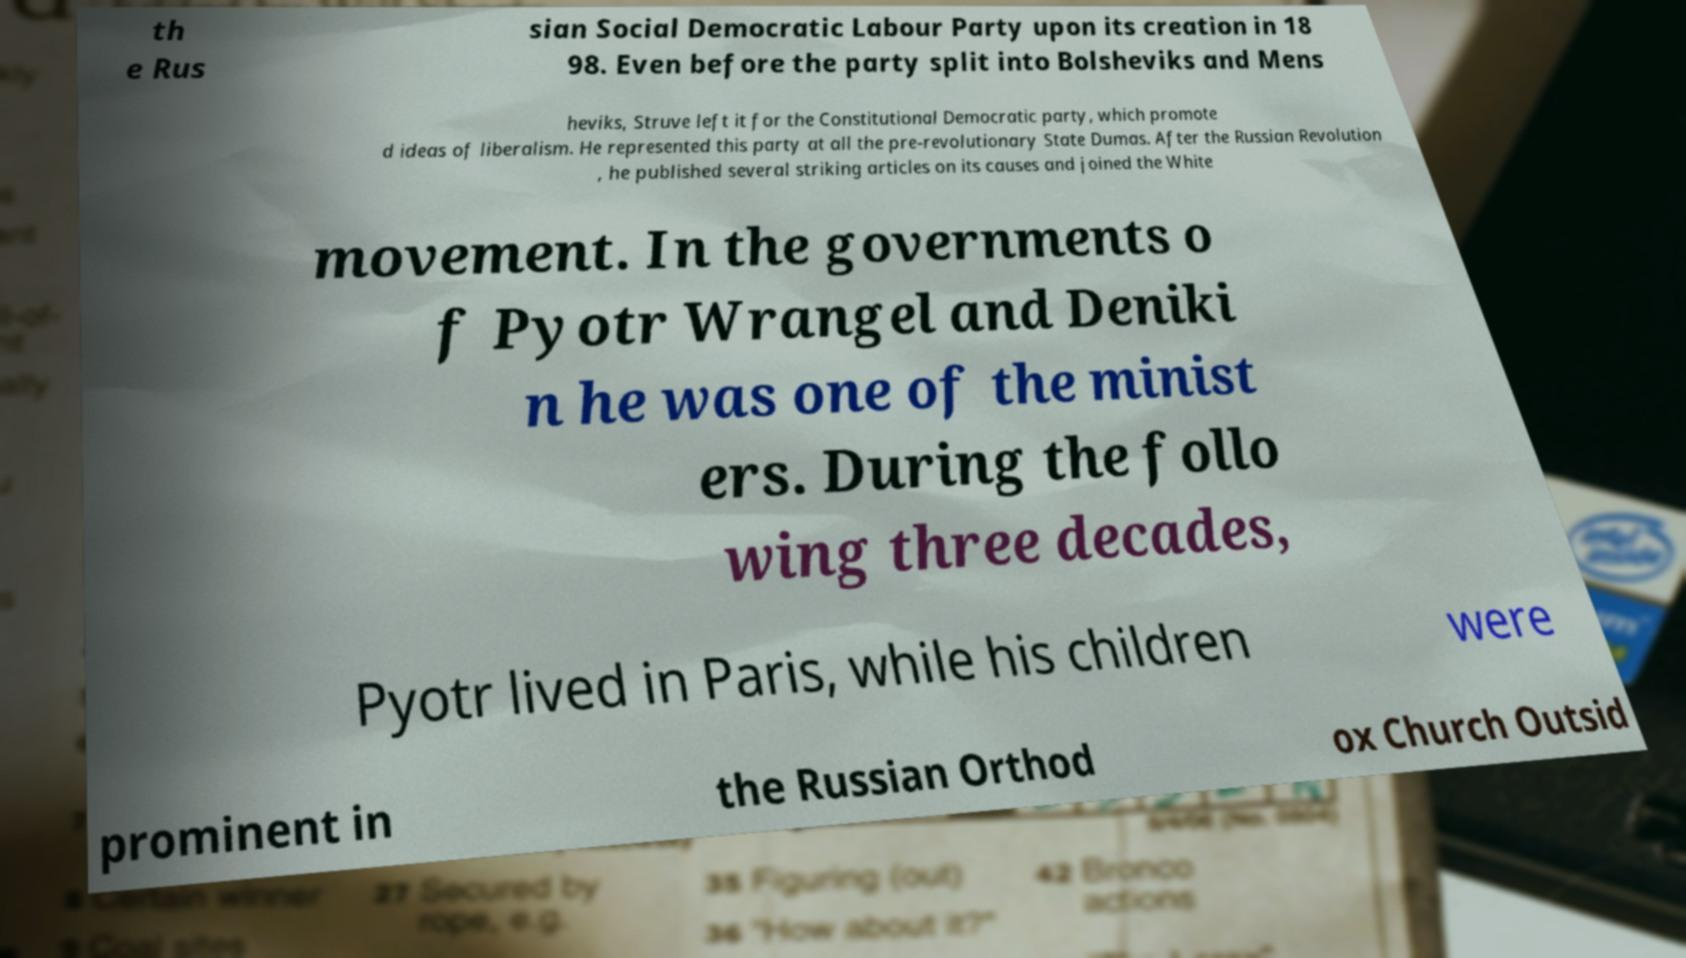There's text embedded in this image that I need extracted. Can you transcribe it verbatim? th e Rus sian Social Democratic Labour Party upon its creation in 18 98. Even before the party split into Bolsheviks and Mens heviks, Struve left it for the Constitutional Democratic party, which promote d ideas of liberalism. He represented this party at all the pre-revolutionary State Dumas. After the Russian Revolution , he published several striking articles on its causes and joined the White movement. In the governments o f Pyotr Wrangel and Deniki n he was one of the minist ers. During the follo wing three decades, Pyotr lived in Paris, while his children were prominent in the Russian Orthod ox Church Outsid 